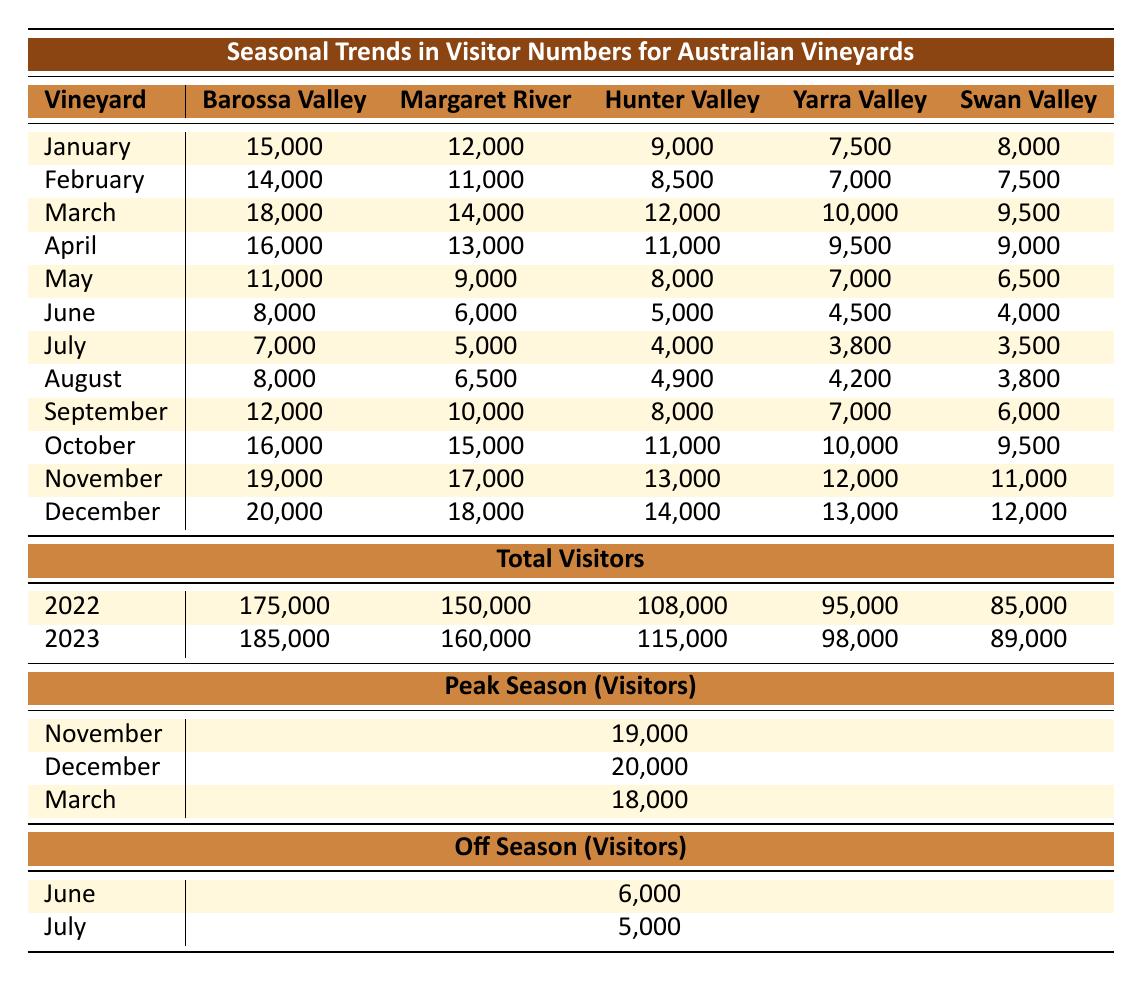What is the total number of visitors for the Barossa Valley in 2022? The total visitors for Barossa Valley in 2022 is listed in the "Total Visitors" section under 2022, which shows 175,000 visitors.
Answer: 175,000 Which month had the highest number of visitors for Hunter Valley? By looking at the "Monthly Visitors" section, the highest visitor number for Hunter Valley is in December with 14,000 visitors.
Answer: December What is the average number of visitors in May across all vineyards? To find the average for May, add the number of visitors: 11,000 + 9,000 + 8,000 + 7,000 + 6,500 = 41,500. Then divide by 5 (the number of vineyards): 41,500 / 5 = 8,300.
Answer: 8,300 Is July considered a peak season for any of the vineyards? In the "Peak Season" section, July is not listed among the peak months, which are November, December, and March. Thus, July is not a peak month.
Answer: No For which vineyard is April the highest month for visitors? By checking the monthly visitor numbers for April, there are no instances of April being the highest for any vineyard; higher visitor counts occur in March, November, or December for these vineyards, making April an off-peak month.
Answer: None What is the total visitor count for all vineyards in the peak month of December? First, identify December's visitor numbers: Barossa Valley: 20,000, Margaret River: 18,000, Hunter Valley: 14,000, Yarra Valley: 13,000, Swan Valley: 12,000. Adding these gives: 20,000 + 18,000 + 14,000 + 13,000 + 12,000 = 77,000.
Answer: 77,000 Which vineyard saw the greatest increase in total visitors from 2022 to 2023? Observe the total visitors for each vineyard in both years: Barossa Valley increased by 10,000 (175,000 to 185,000), Margaret River by 10,000 (150,000 to 160,000), Hunter Valley by 7,000, Yarra Valley by 3,000, and Swan Valley by 4,000. The largest increase occurred in Barossa Valley and Margaret River, both by 10,000.
Answer: Barossa Valley and Margaret River During the off-season months of June and July, which vineyard had the highest number of visitors? From the "Off Season" section, June shows Barossa Valley with 8,000 visitors and July with 7,000. Thus the highest visitor count in June or July is for Barossa Valley in June.
Answer: Barossa Valley What is the percentage decrease in visitors for Yarra Valley from July to June? In July, Yarra Valley had 3,800 visitors and in June 4,500. The decrease is 4,500 - 3,800 = 700. To find the percentage decrease: (700 / 4,500) x 100 = 15.56%.
Answer: 15.56% Are the visitor counts for Swan Valley higher in October compared to February? Looking at the numbers, Swan Valley had 9,500 visitors in October and 7,500 in February, indicating October has a higher visitor count than February for Swan Valley.
Answer: Yes 